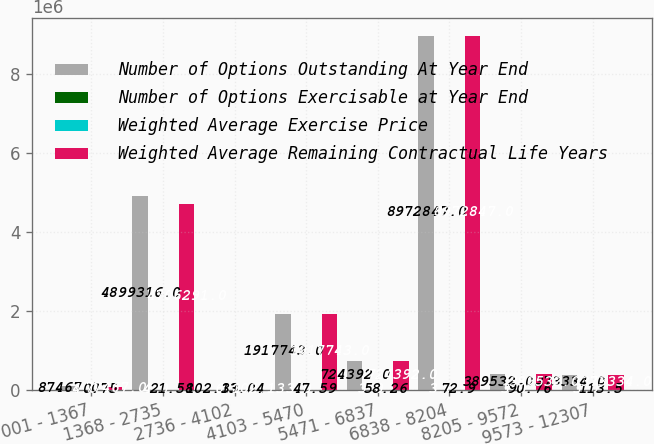Convert chart. <chart><loc_0><loc_0><loc_500><loc_500><stacked_bar_chart><ecel><fcel>001 - 1367<fcel>1368 - 2735<fcel>2736 - 4102<fcel>4103 - 5470<fcel>5471 - 6837<fcel>6838 - 8204<fcel>8205 - 9572<fcel>9573 - 12307<nl><fcel>Number of Options Outstanding At Year End<fcel>87467<fcel>4.89932e+06<fcel>102.13<fcel>1.91774e+06<fcel>724392<fcel>8.97285e+06<fcel>389532<fcel>373334<nl><fcel>Number of Options Exercisable at Year End<fcel>4<fcel>4<fcel>6<fcel>3<fcel>3<fcel>3<fcel>3<fcel>3<nl><fcel>Weighted Average Exercise Price<fcel>0.75<fcel>21.58<fcel>33.04<fcel>47.59<fcel>58.26<fcel>72.9<fcel>90.76<fcel>113.5<nl><fcel>Weighted Average Remaining Contractual Life Years<fcel>77467<fcel>4.70629e+06<fcel>102.13<fcel>1.91774e+06<fcel>724392<fcel>8.97285e+06<fcel>389532<fcel>373334<nl></chart> 